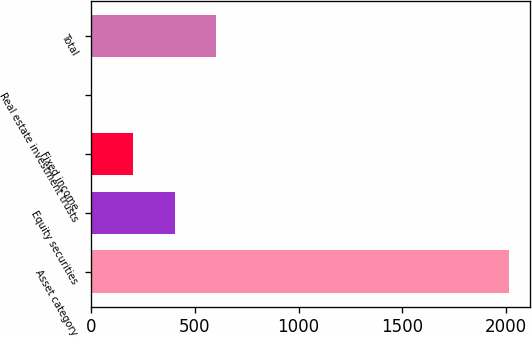Convert chart. <chart><loc_0><loc_0><loc_500><loc_500><bar_chart><fcel>Asset category<fcel>Equity securities<fcel>Fixed income<fcel>Real estate investment trusts<fcel>Total<nl><fcel>2013<fcel>403.4<fcel>202.2<fcel>1<fcel>604.6<nl></chart> 